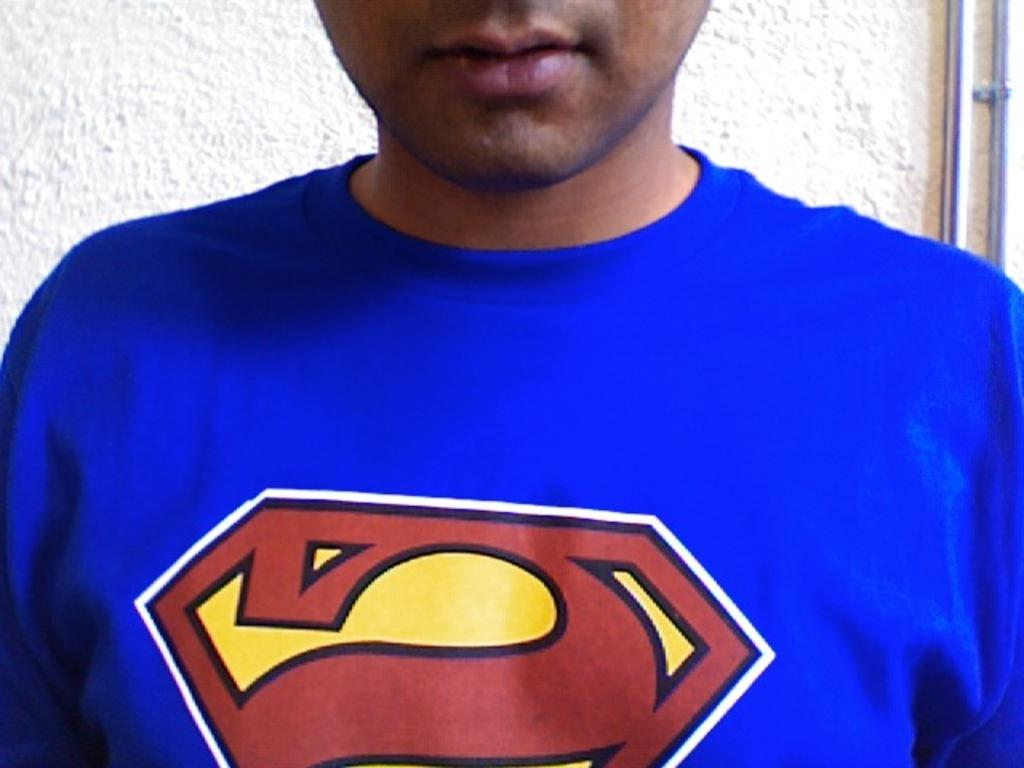What is the main subject in the foreground of the image? There is a person in the foreground of the image. What is the person wearing in the image? The person is wearing a blue t-shirt. What can be seen in the background of the image? There is a wall in the background of the image. What type of skin is visible on the stranger in the image? There is no stranger present in the image, and therefore no skin can be observed. 